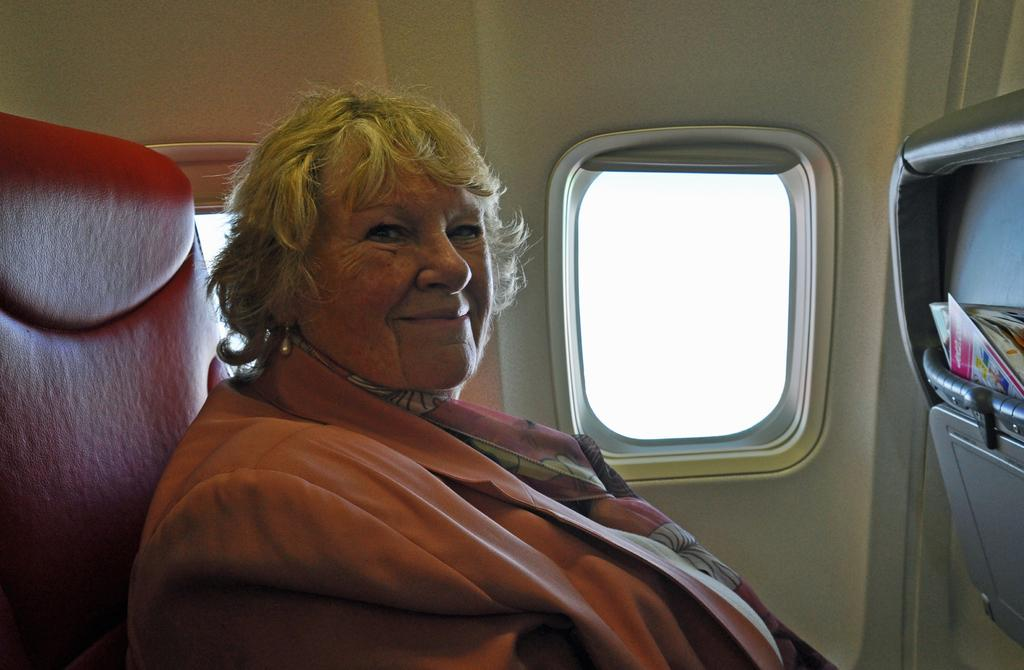Who is present in the image? There is a lady in the image. What is the lady wearing? The lady is wearing a scarf. What is the lady doing in the image? The lady is sitting and smiling. Where is the image taken? The image is inside a flight. What can be seen through the window in the image? The image does not show what is visible through the window. What items are stored in the box on the right side of the image? There are books in a box on the right side of the image. What type of crate is visible on the floor in the image? There is no crate visible on the floor in the image. What causes a spark to appear in the image? There is no spark present in the image. 